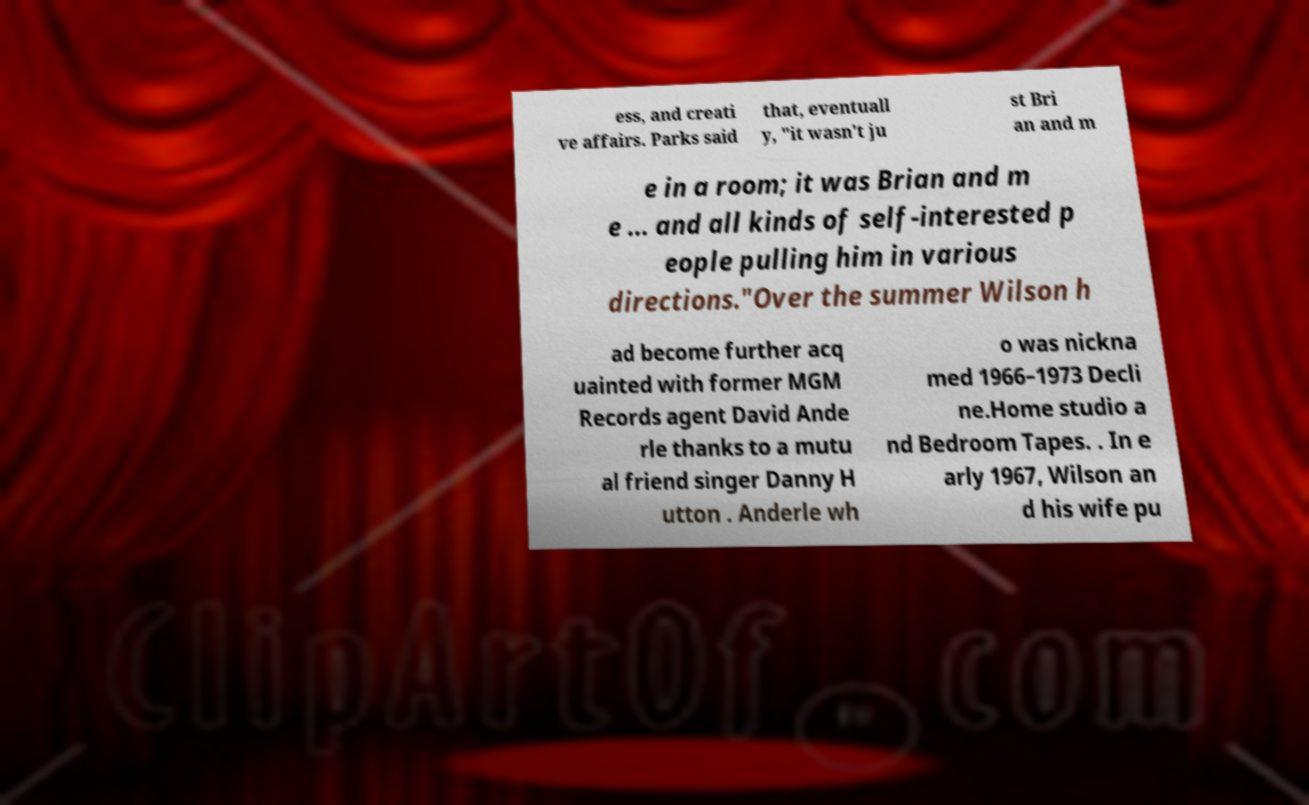Could you assist in decoding the text presented in this image and type it out clearly? ess, and creati ve affairs. Parks said that, eventuall y, "it wasn't ju st Bri an and m e in a room; it was Brian and m e ... and all kinds of self-interested p eople pulling him in various directions."Over the summer Wilson h ad become further acq uainted with former MGM Records agent David Ande rle thanks to a mutu al friend singer Danny H utton . Anderle wh o was nickna med 1966–1973 Decli ne.Home studio a nd Bedroom Tapes. . In e arly 1967, Wilson an d his wife pu 